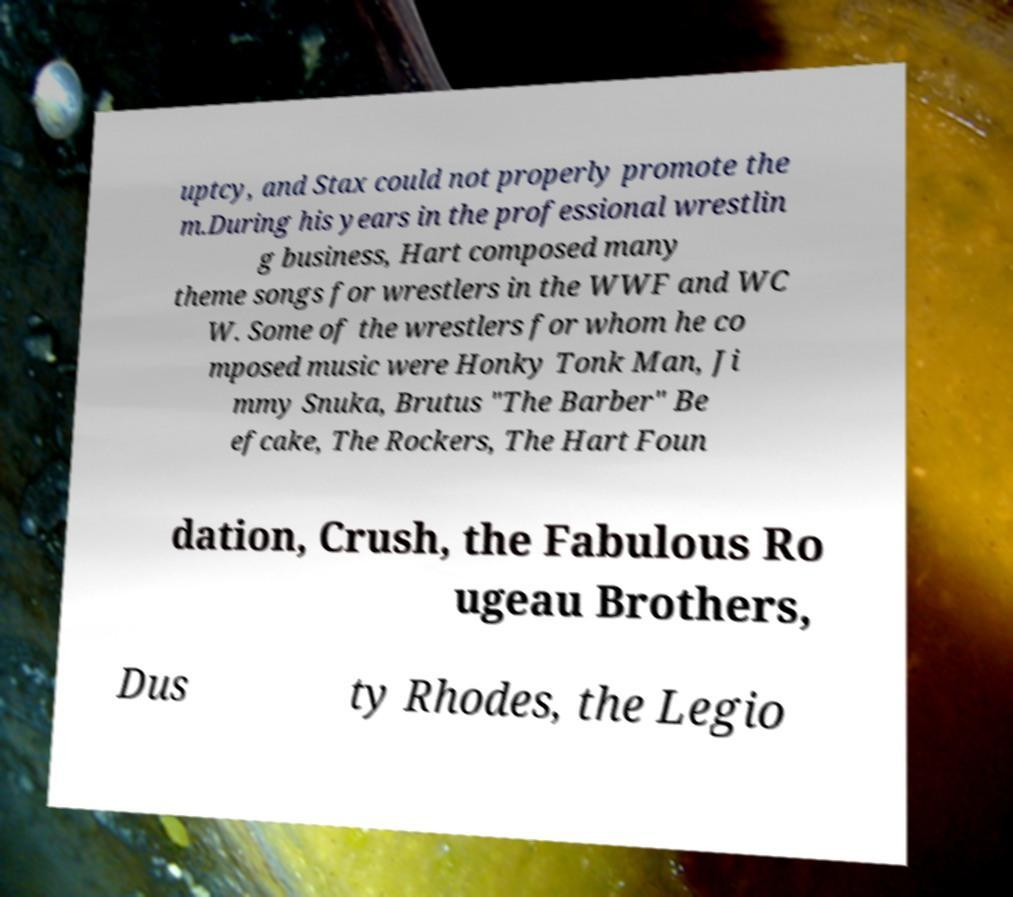Can you read and provide the text displayed in the image?This photo seems to have some interesting text. Can you extract and type it out for me? uptcy, and Stax could not properly promote the m.During his years in the professional wrestlin g business, Hart composed many theme songs for wrestlers in the WWF and WC W. Some of the wrestlers for whom he co mposed music were Honky Tonk Man, Ji mmy Snuka, Brutus "The Barber" Be efcake, The Rockers, The Hart Foun dation, Crush, the Fabulous Ro ugeau Brothers, Dus ty Rhodes, the Legio 